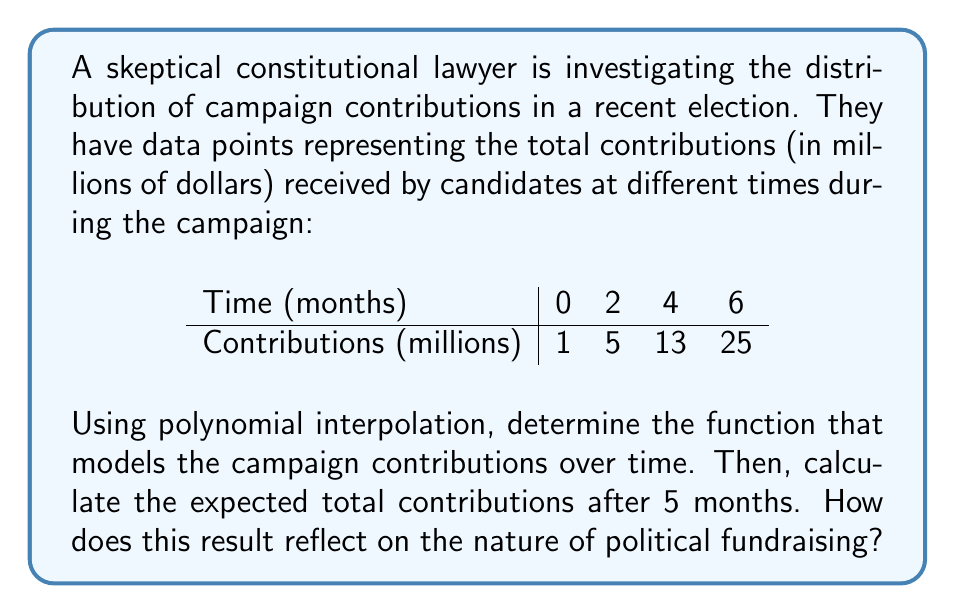Give your solution to this math problem. Let's approach this step-by-step:

1) We have 4 data points, so we'll use a 3rd degree polynomial of the form:
   $f(x) = ax^3 + bx^2 + cx + d$

2) We need to solve the system of equations:
   $f(0) = d = 1$
   $f(2) = 8a + 4b + 2c + d = 5$
   $f(4) = 64a + 16b + 4c + d = 13$
   $f(6) = 216a + 36b + 6c + d = 25$

3) Substituting $d = 1$ and subtracting the first equation from the others:
   $8a + 4b + 2c = 4$
   $64a + 16b + 4c = 12$
   $216a + 36b + 6c = 24$

4) Using Gaussian elimination or a matrix solver, we get:
   $a = \frac{1}{8}, b = 0, c = \frac{3}{2}, d = 1$

5) Therefore, our polynomial is:
   $f(x) = \frac{1}{8}x^3 + \frac{3}{2}x + 1$

6) To find the contributions after 5 months, we calculate $f(5)$:
   $f(5) = \frac{1}{8}(125) + \frac{3}{2}(5) + 1 = 15.625 + 7.5 + 1 = 24.125$

This rapid growth in contributions over a short period reflects the intense nature of political fundraising and the increasing influence of money in politics.
Answer: $f(x) = \frac{1}{8}x^3 + \frac{3}{2}x + 1$; $24.125 million after 5 months 